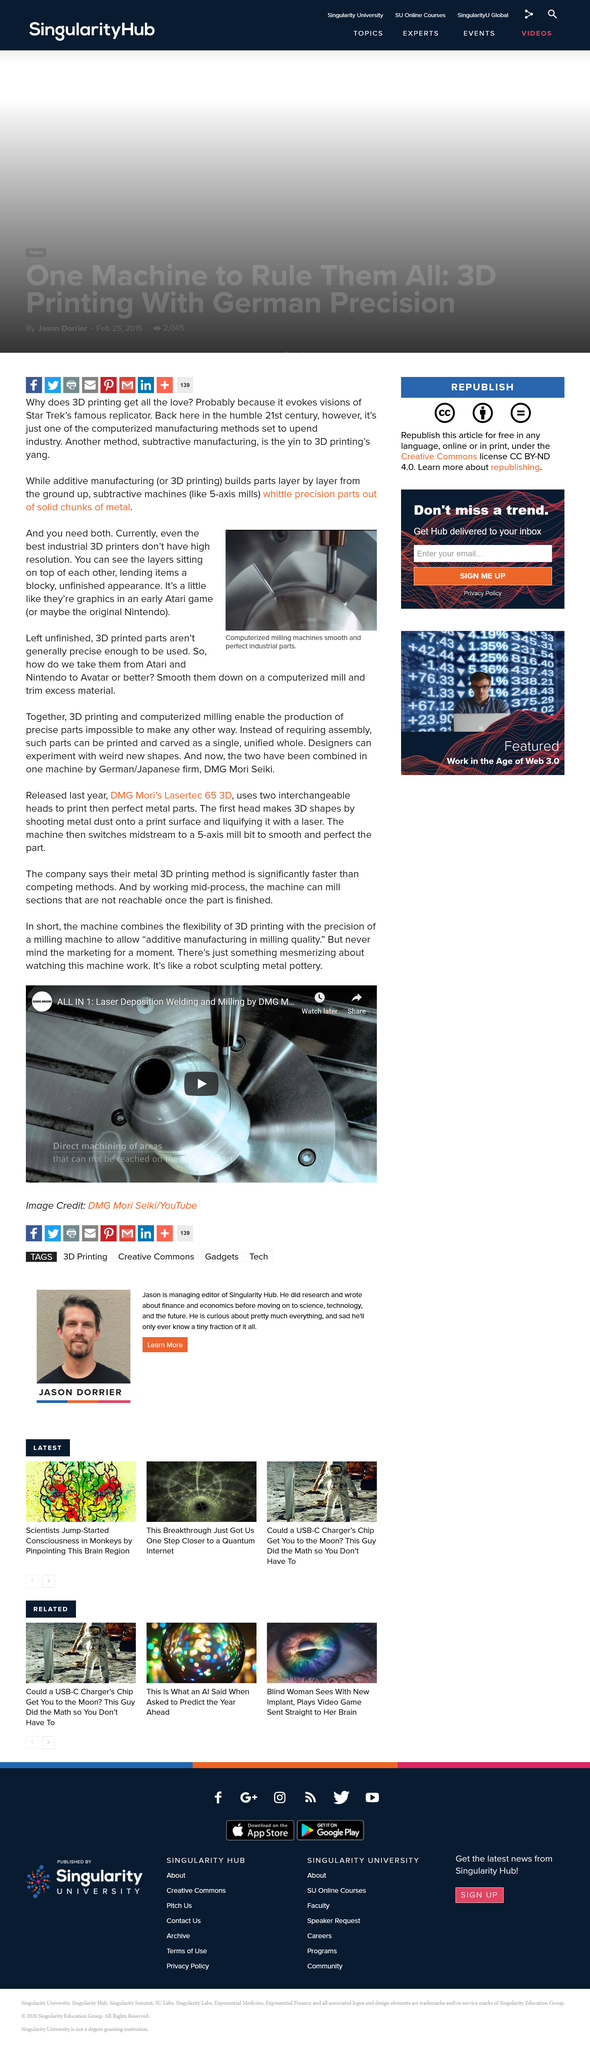Point out several critical features in this image. The low resolution of current 3D printers is the primary cause of the blocky appearance of most 3D printed parts, resulting in an unfinished appearance where the layers can be seen laying on top of each other. Additive manufacturing, also known as 3D printing, is a process where materials are added layer by layer to create a physical object. The counterpart to additive manufacturing is subtractive manufacturing, which involves removing material to create a desired shape. Computerized milling machines are commonly used to finish and refine 3D printed parts as they are often too rough to be used as is. 